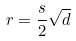<formula> <loc_0><loc_0><loc_500><loc_500>r = \frac { s } { 2 } \sqrt { d }</formula> 